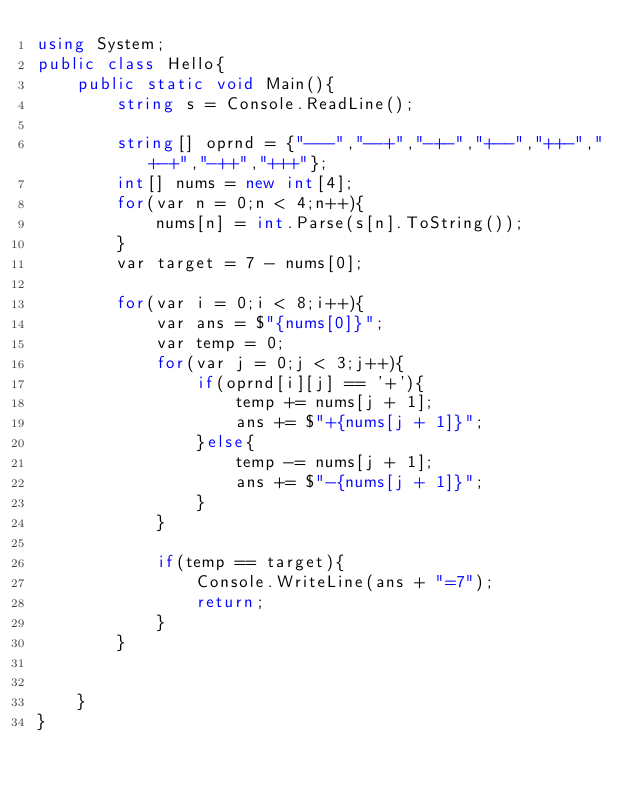Convert code to text. <code><loc_0><loc_0><loc_500><loc_500><_C#_>using System;
public class Hello{
    public static void Main(){
        string s = Console.ReadLine();
        
        string[] oprnd = {"---","--+","-+-","+--","++-","+-+","-++","+++"};
        int[] nums = new int[4];
        for(var n = 0;n < 4;n++){
            nums[n] = int.Parse(s[n].ToString());
        }
        var target = 7 - nums[0];
 
        for(var i = 0;i < 8;i++){
            var ans = $"{nums[0]}";
            var temp = 0;
            for(var j = 0;j < 3;j++){
                if(oprnd[i][j] == '+'){
                    temp += nums[j + 1];
                    ans += $"+{nums[j + 1]}";
                }else{
                    temp -= nums[j + 1];
                    ans += $"-{nums[j + 1]}";
                }
            }
            
            if(temp == target){
                Console.WriteLine(ans + "=7");
                return;
            }
        }
        
        
    }
}
</code> 